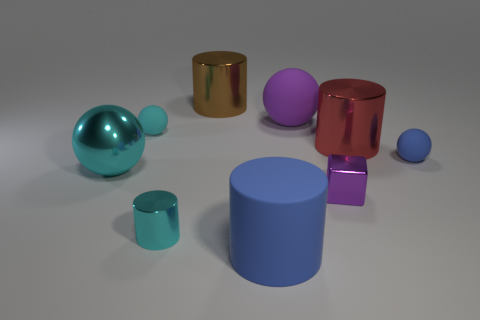What might the size relationships between objects suggest? The size relationships between objects could suggest a sense of perspective or could be interpreted as a metaphor for the variety of entities in a system. The larger shapes might represent primary elements or characters, while the smaller ones could symbolize secondary or supporting entities. 